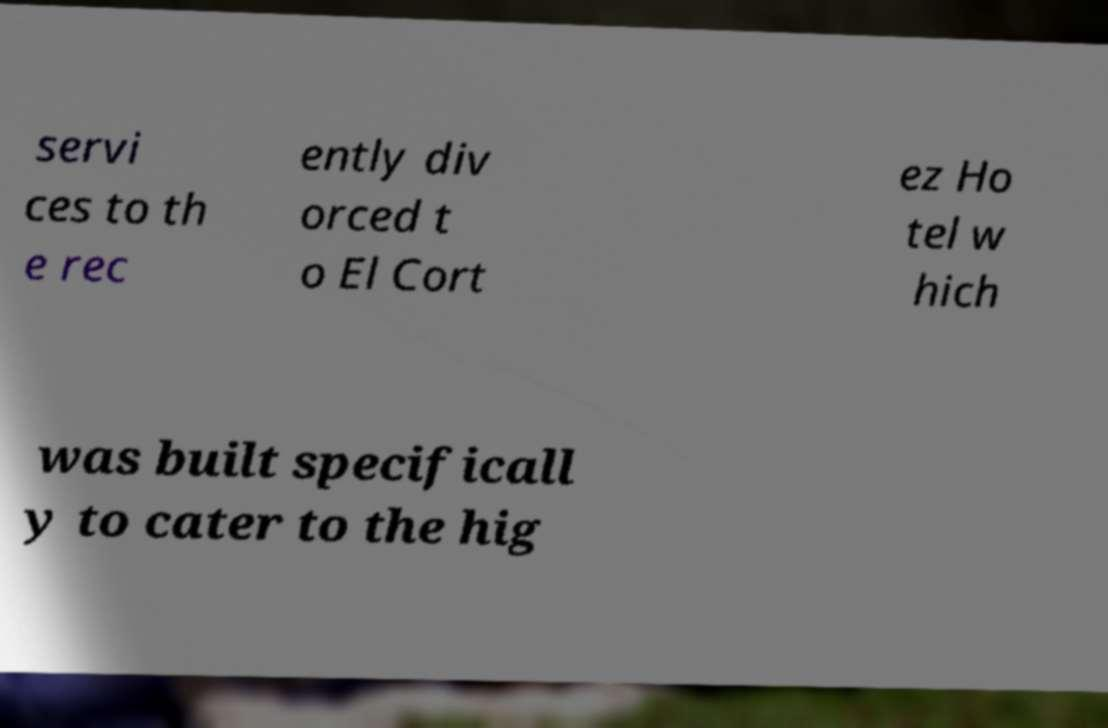Please identify and transcribe the text found in this image. servi ces to th e rec ently div orced t o El Cort ez Ho tel w hich was built specificall y to cater to the hig 